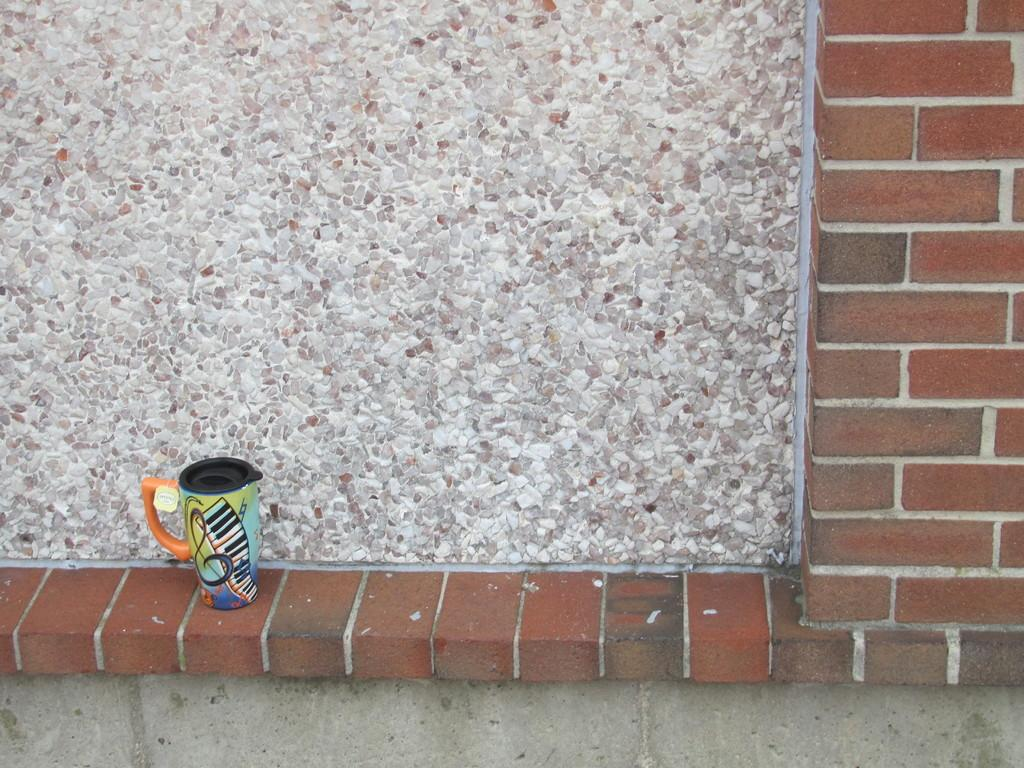What object is located on the left side of the image? There is a mug on the left side of the image. Where is the mug positioned in the image? The mug is placed on a wall. What type of wall can be seen in the background of the image? There is a stone wall in the background of the image. What type of glove is hanging on the stone wall in the image? There is no glove present in the image; it only features a mug placed on a wall and a stone wall in the background. 